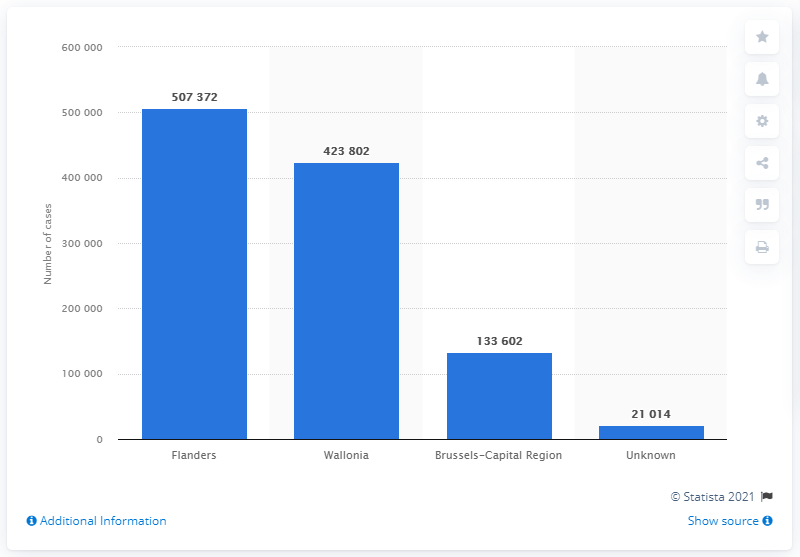Mention a couple of crucial points in this snapshot. There were 133,602 positive tests registered in the Brussels-Capital Region. There were 423,802 confirmed cases of COVID-19 in Wallonia as of March 28, 2023. As of June 30, 2021, a total of 507,372 positive test results were reported in Flanders. 